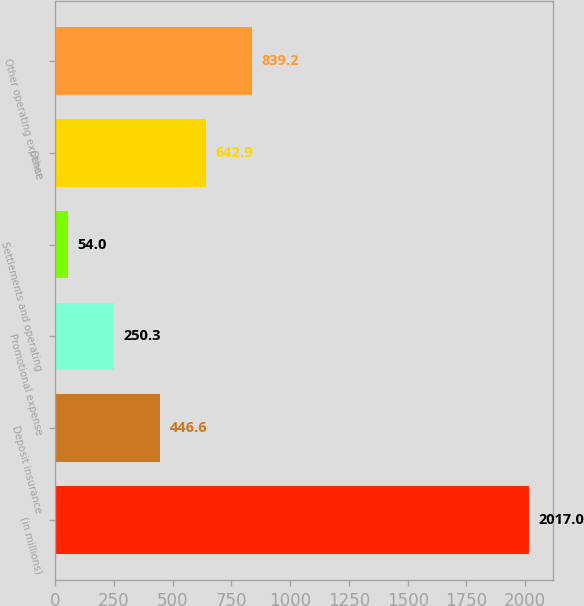Convert chart. <chart><loc_0><loc_0><loc_500><loc_500><bar_chart><fcel>(in millions)<fcel>Deposit insurance<fcel>Promotional expense<fcel>Settlements and operating<fcel>Other<fcel>Other operating expense<nl><fcel>2017<fcel>446.6<fcel>250.3<fcel>54<fcel>642.9<fcel>839.2<nl></chart> 